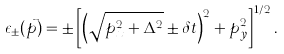Convert formula to latex. <formula><loc_0><loc_0><loc_500><loc_500>\epsilon _ { \pm } ( \vec { p } ) = \pm \left [ \left ( \sqrt { p _ { x } ^ { 2 } + \Delta ^ { 2 } } \pm \delta { t } \right ) ^ { 2 } + p _ { y } ^ { 2 } \right ] ^ { 1 / 2 } .</formula> 